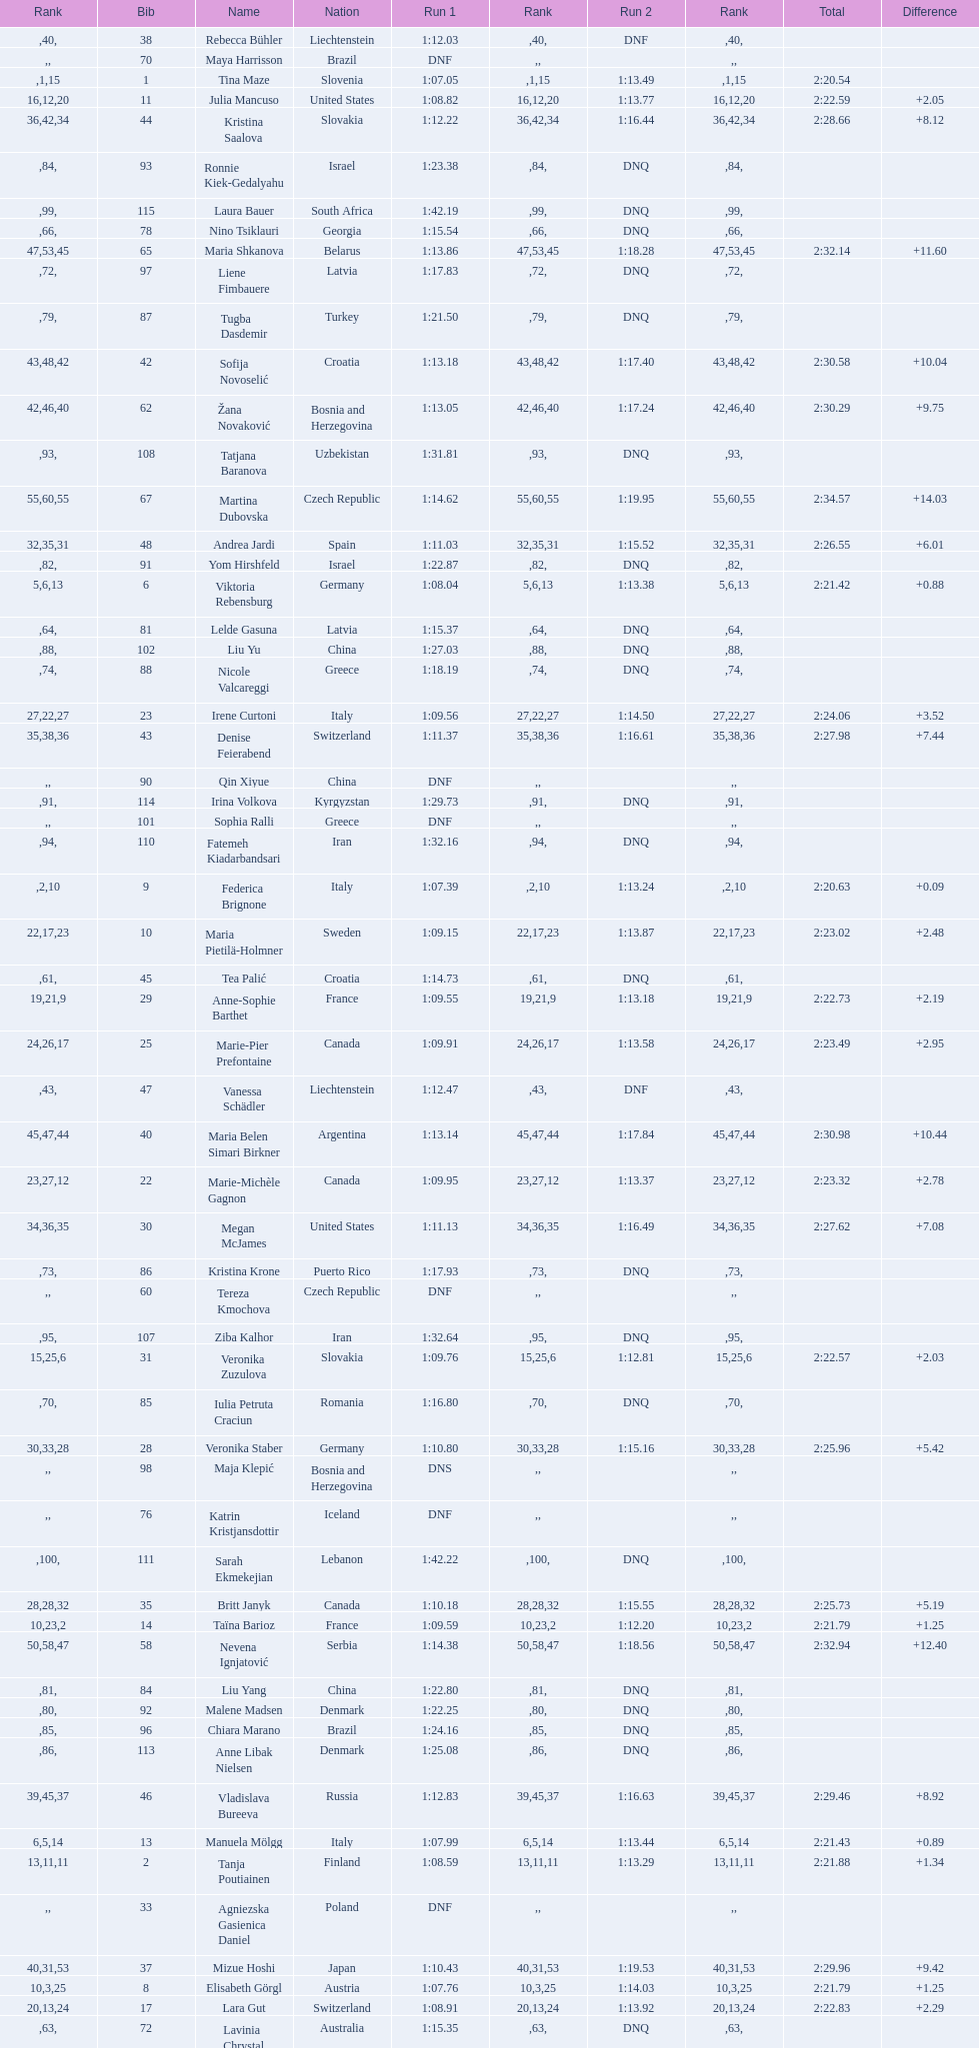What is the last nation to be ranked? Czech Republic. 